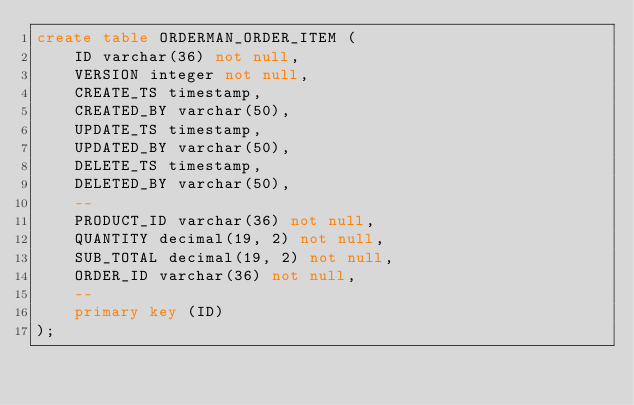Convert code to text. <code><loc_0><loc_0><loc_500><loc_500><_SQL_>create table ORDERMAN_ORDER_ITEM (
    ID varchar(36) not null,
    VERSION integer not null,
    CREATE_TS timestamp,
    CREATED_BY varchar(50),
    UPDATE_TS timestamp,
    UPDATED_BY varchar(50),
    DELETE_TS timestamp,
    DELETED_BY varchar(50),
    --
    PRODUCT_ID varchar(36) not null,
    QUANTITY decimal(19, 2) not null,
    SUB_TOTAL decimal(19, 2) not null,
    ORDER_ID varchar(36) not null,
    --
    primary key (ID)
);
</code> 